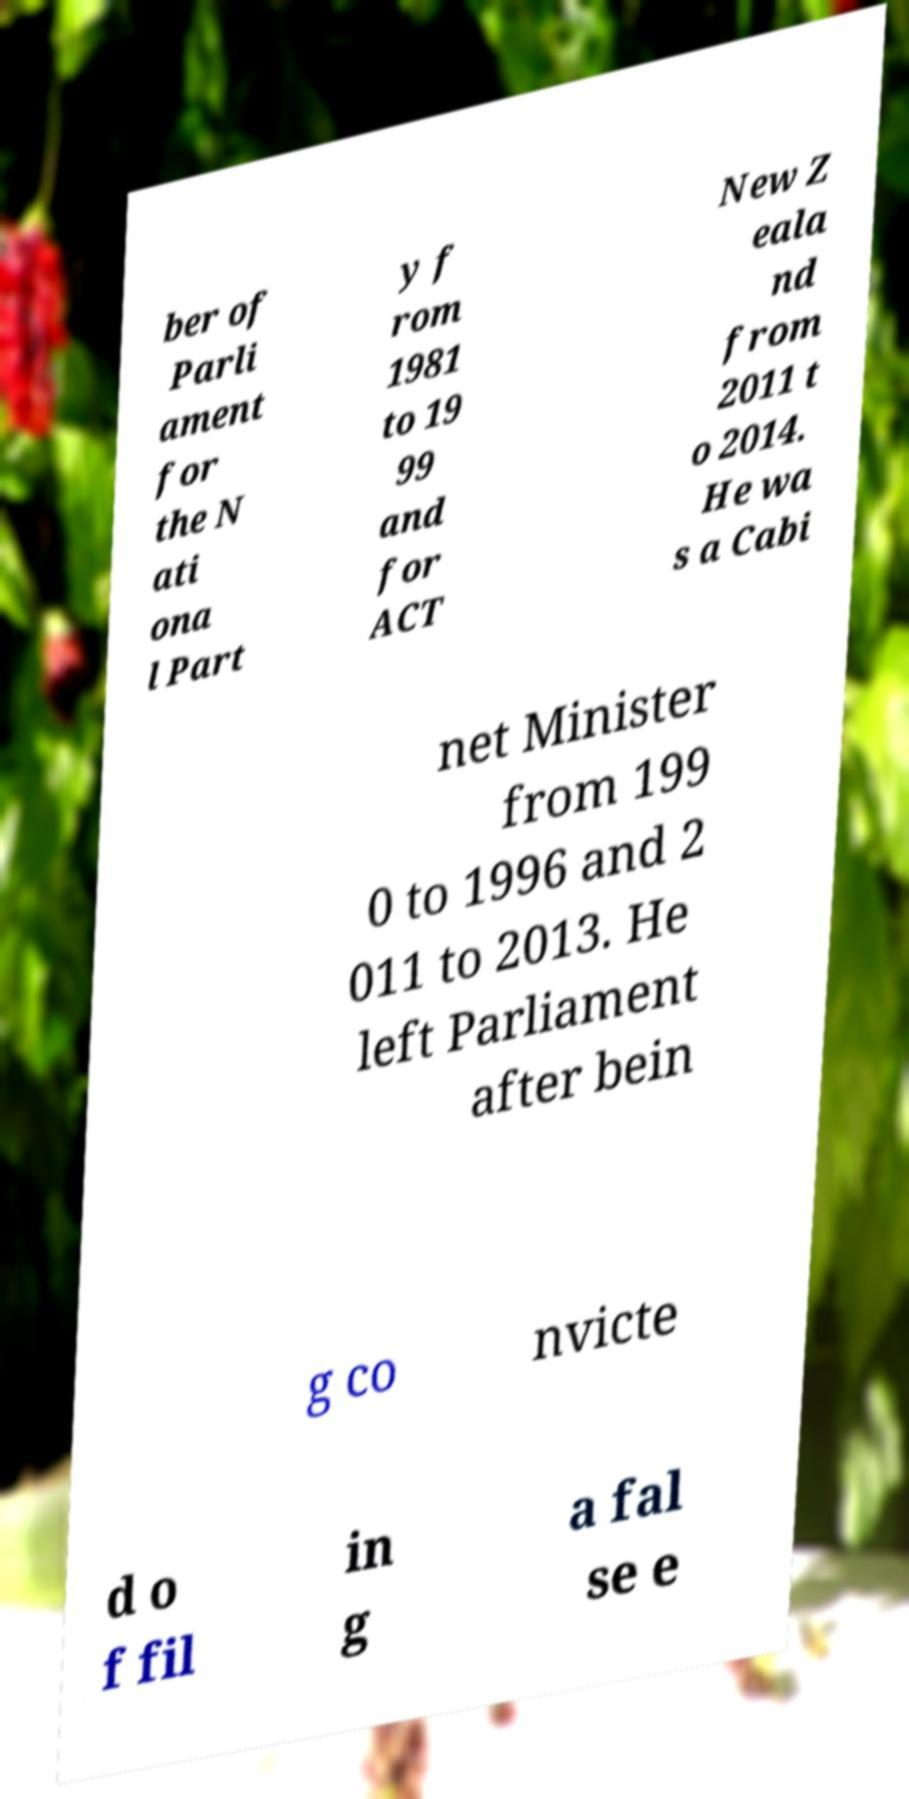What messages or text are displayed in this image? I need them in a readable, typed format. ber of Parli ament for the N ati ona l Part y f rom 1981 to 19 99 and for ACT New Z eala nd from 2011 t o 2014. He wa s a Cabi net Minister from 199 0 to 1996 and 2 011 to 2013. He left Parliament after bein g co nvicte d o f fil in g a fal se e 